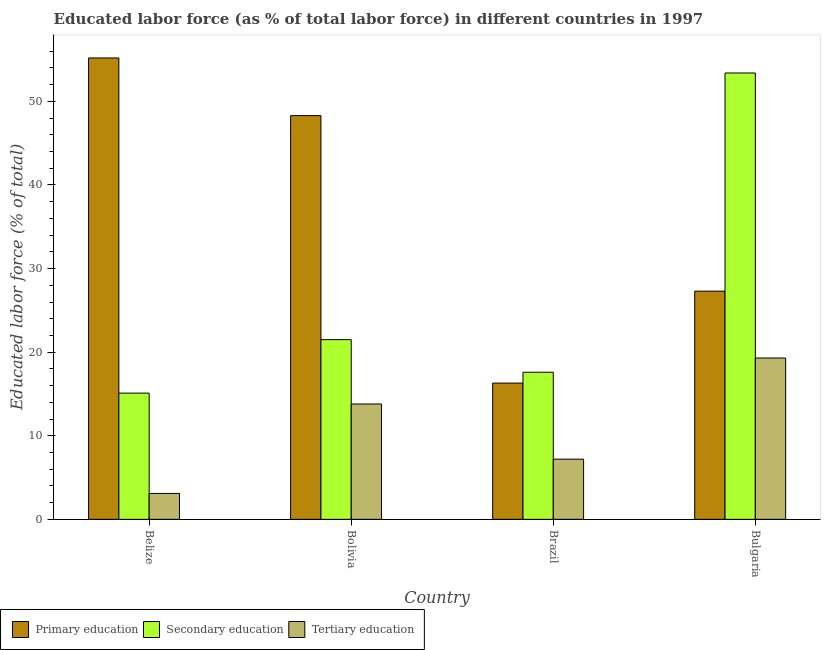Are the number of bars on each tick of the X-axis equal?
Your response must be concise. Yes. How many bars are there on the 2nd tick from the right?
Make the answer very short. 3. What is the label of the 3rd group of bars from the left?
Offer a very short reply. Brazil. In how many cases, is the number of bars for a given country not equal to the number of legend labels?
Make the answer very short. 0. What is the percentage of labor force who received primary education in Belize?
Make the answer very short. 55.2. Across all countries, what is the maximum percentage of labor force who received tertiary education?
Provide a short and direct response. 19.3. Across all countries, what is the minimum percentage of labor force who received secondary education?
Your response must be concise. 15.1. In which country was the percentage of labor force who received primary education maximum?
Your response must be concise. Belize. In which country was the percentage of labor force who received primary education minimum?
Offer a very short reply. Brazil. What is the total percentage of labor force who received primary education in the graph?
Make the answer very short. 147.1. What is the difference between the percentage of labor force who received primary education in Belize and that in Bulgaria?
Provide a short and direct response. 27.9. What is the difference between the percentage of labor force who received secondary education in Bolivia and the percentage of labor force who received primary education in Bulgaria?
Keep it short and to the point. -5.8. What is the average percentage of labor force who received primary education per country?
Provide a short and direct response. 36.77. What is the difference between the percentage of labor force who received primary education and percentage of labor force who received tertiary education in Belize?
Keep it short and to the point. 52.1. What is the ratio of the percentage of labor force who received primary education in Belize to that in Brazil?
Provide a succinct answer. 3.39. Is the percentage of labor force who received primary education in Belize less than that in Brazil?
Provide a short and direct response. No. What is the difference between the highest and the second highest percentage of labor force who received tertiary education?
Your answer should be very brief. 5.5. What is the difference between the highest and the lowest percentage of labor force who received secondary education?
Give a very brief answer. 38.3. Is the sum of the percentage of labor force who received primary education in Belize and Bolivia greater than the maximum percentage of labor force who received tertiary education across all countries?
Offer a very short reply. Yes. What does the 2nd bar from the left in Bulgaria represents?
Provide a short and direct response. Secondary education. What does the 1st bar from the right in Bulgaria represents?
Keep it short and to the point. Tertiary education. How many bars are there?
Ensure brevity in your answer.  12. Are all the bars in the graph horizontal?
Keep it short and to the point. No. How many countries are there in the graph?
Give a very brief answer. 4. What is the difference between two consecutive major ticks on the Y-axis?
Provide a short and direct response. 10. Are the values on the major ticks of Y-axis written in scientific E-notation?
Provide a succinct answer. No. Does the graph contain any zero values?
Your answer should be very brief. No. Where does the legend appear in the graph?
Your answer should be compact. Bottom left. How many legend labels are there?
Provide a short and direct response. 3. What is the title of the graph?
Ensure brevity in your answer.  Educated labor force (as % of total labor force) in different countries in 1997. Does "Poland" appear as one of the legend labels in the graph?
Your answer should be compact. No. What is the label or title of the Y-axis?
Offer a terse response. Educated labor force (% of total). What is the Educated labor force (% of total) of Primary education in Belize?
Ensure brevity in your answer.  55.2. What is the Educated labor force (% of total) of Secondary education in Belize?
Make the answer very short. 15.1. What is the Educated labor force (% of total) of Tertiary education in Belize?
Provide a short and direct response. 3.1. What is the Educated labor force (% of total) of Primary education in Bolivia?
Your answer should be compact. 48.3. What is the Educated labor force (% of total) in Tertiary education in Bolivia?
Keep it short and to the point. 13.8. What is the Educated labor force (% of total) in Primary education in Brazil?
Keep it short and to the point. 16.3. What is the Educated labor force (% of total) in Secondary education in Brazil?
Provide a succinct answer. 17.6. What is the Educated labor force (% of total) in Tertiary education in Brazil?
Ensure brevity in your answer.  7.2. What is the Educated labor force (% of total) in Primary education in Bulgaria?
Your answer should be compact. 27.3. What is the Educated labor force (% of total) of Secondary education in Bulgaria?
Make the answer very short. 53.4. What is the Educated labor force (% of total) of Tertiary education in Bulgaria?
Offer a terse response. 19.3. Across all countries, what is the maximum Educated labor force (% of total) of Primary education?
Provide a succinct answer. 55.2. Across all countries, what is the maximum Educated labor force (% of total) of Secondary education?
Your response must be concise. 53.4. Across all countries, what is the maximum Educated labor force (% of total) in Tertiary education?
Keep it short and to the point. 19.3. Across all countries, what is the minimum Educated labor force (% of total) of Primary education?
Offer a very short reply. 16.3. Across all countries, what is the minimum Educated labor force (% of total) of Secondary education?
Ensure brevity in your answer.  15.1. Across all countries, what is the minimum Educated labor force (% of total) of Tertiary education?
Your response must be concise. 3.1. What is the total Educated labor force (% of total) in Primary education in the graph?
Your answer should be compact. 147.1. What is the total Educated labor force (% of total) of Secondary education in the graph?
Your response must be concise. 107.6. What is the total Educated labor force (% of total) of Tertiary education in the graph?
Provide a succinct answer. 43.4. What is the difference between the Educated labor force (% of total) of Tertiary education in Belize and that in Bolivia?
Offer a terse response. -10.7. What is the difference between the Educated labor force (% of total) of Primary education in Belize and that in Brazil?
Give a very brief answer. 38.9. What is the difference between the Educated labor force (% of total) of Secondary education in Belize and that in Brazil?
Ensure brevity in your answer.  -2.5. What is the difference between the Educated labor force (% of total) of Tertiary education in Belize and that in Brazil?
Your response must be concise. -4.1. What is the difference between the Educated labor force (% of total) in Primary education in Belize and that in Bulgaria?
Your answer should be very brief. 27.9. What is the difference between the Educated labor force (% of total) in Secondary education in Belize and that in Bulgaria?
Offer a terse response. -38.3. What is the difference between the Educated labor force (% of total) of Tertiary education in Belize and that in Bulgaria?
Provide a succinct answer. -16.2. What is the difference between the Educated labor force (% of total) in Primary education in Bolivia and that in Bulgaria?
Offer a terse response. 21. What is the difference between the Educated labor force (% of total) of Secondary education in Bolivia and that in Bulgaria?
Your response must be concise. -31.9. What is the difference between the Educated labor force (% of total) of Primary education in Brazil and that in Bulgaria?
Offer a terse response. -11. What is the difference between the Educated labor force (% of total) of Secondary education in Brazil and that in Bulgaria?
Provide a succinct answer. -35.8. What is the difference between the Educated labor force (% of total) of Tertiary education in Brazil and that in Bulgaria?
Provide a succinct answer. -12.1. What is the difference between the Educated labor force (% of total) of Primary education in Belize and the Educated labor force (% of total) of Secondary education in Bolivia?
Keep it short and to the point. 33.7. What is the difference between the Educated labor force (% of total) of Primary education in Belize and the Educated labor force (% of total) of Tertiary education in Bolivia?
Give a very brief answer. 41.4. What is the difference between the Educated labor force (% of total) of Primary education in Belize and the Educated labor force (% of total) of Secondary education in Brazil?
Give a very brief answer. 37.6. What is the difference between the Educated labor force (% of total) in Primary education in Belize and the Educated labor force (% of total) in Tertiary education in Brazil?
Keep it short and to the point. 48. What is the difference between the Educated labor force (% of total) in Primary education in Belize and the Educated labor force (% of total) in Secondary education in Bulgaria?
Provide a succinct answer. 1.8. What is the difference between the Educated labor force (% of total) of Primary education in Belize and the Educated labor force (% of total) of Tertiary education in Bulgaria?
Your answer should be compact. 35.9. What is the difference between the Educated labor force (% of total) of Primary education in Bolivia and the Educated labor force (% of total) of Secondary education in Brazil?
Your answer should be very brief. 30.7. What is the difference between the Educated labor force (% of total) in Primary education in Bolivia and the Educated labor force (% of total) in Tertiary education in Brazil?
Provide a succinct answer. 41.1. What is the difference between the Educated labor force (% of total) in Primary education in Bolivia and the Educated labor force (% of total) in Tertiary education in Bulgaria?
Offer a very short reply. 29. What is the difference between the Educated labor force (% of total) in Primary education in Brazil and the Educated labor force (% of total) in Secondary education in Bulgaria?
Ensure brevity in your answer.  -37.1. What is the average Educated labor force (% of total) of Primary education per country?
Offer a very short reply. 36.77. What is the average Educated labor force (% of total) in Secondary education per country?
Offer a terse response. 26.9. What is the average Educated labor force (% of total) of Tertiary education per country?
Your answer should be compact. 10.85. What is the difference between the Educated labor force (% of total) in Primary education and Educated labor force (% of total) in Secondary education in Belize?
Offer a terse response. 40.1. What is the difference between the Educated labor force (% of total) of Primary education and Educated labor force (% of total) of Tertiary education in Belize?
Your answer should be very brief. 52.1. What is the difference between the Educated labor force (% of total) in Primary education and Educated labor force (% of total) in Secondary education in Bolivia?
Provide a succinct answer. 26.8. What is the difference between the Educated labor force (% of total) in Primary education and Educated labor force (% of total) in Tertiary education in Bolivia?
Offer a terse response. 34.5. What is the difference between the Educated labor force (% of total) in Secondary education and Educated labor force (% of total) in Tertiary education in Bolivia?
Your response must be concise. 7.7. What is the difference between the Educated labor force (% of total) of Primary education and Educated labor force (% of total) of Secondary education in Brazil?
Keep it short and to the point. -1.3. What is the difference between the Educated labor force (% of total) of Secondary education and Educated labor force (% of total) of Tertiary education in Brazil?
Provide a succinct answer. 10.4. What is the difference between the Educated labor force (% of total) of Primary education and Educated labor force (% of total) of Secondary education in Bulgaria?
Your answer should be compact. -26.1. What is the difference between the Educated labor force (% of total) of Primary education and Educated labor force (% of total) of Tertiary education in Bulgaria?
Make the answer very short. 8. What is the difference between the Educated labor force (% of total) of Secondary education and Educated labor force (% of total) of Tertiary education in Bulgaria?
Your response must be concise. 34.1. What is the ratio of the Educated labor force (% of total) in Primary education in Belize to that in Bolivia?
Make the answer very short. 1.14. What is the ratio of the Educated labor force (% of total) of Secondary education in Belize to that in Bolivia?
Offer a very short reply. 0.7. What is the ratio of the Educated labor force (% of total) of Tertiary education in Belize to that in Bolivia?
Keep it short and to the point. 0.22. What is the ratio of the Educated labor force (% of total) of Primary education in Belize to that in Brazil?
Ensure brevity in your answer.  3.39. What is the ratio of the Educated labor force (% of total) of Secondary education in Belize to that in Brazil?
Your answer should be compact. 0.86. What is the ratio of the Educated labor force (% of total) of Tertiary education in Belize to that in Brazil?
Keep it short and to the point. 0.43. What is the ratio of the Educated labor force (% of total) of Primary education in Belize to that in Bulgaria?
Ensure brevity in your answer.  2.02. What is the ratio of the Educated labor force (% of total) in Secondary education in Belize to that in Bulgaria?
Provide a succinct answer. 0.28. What is the ratio of the Educated labor force (% of total) in Tertiary education in Belize to that in Bulgaria?
Give a very brief answer. 0.16. What is the ratio of the Educated labor force (% of total) of Primary education in Bolivia to that in Brazil?
Your answer should be very brief. 2.96. What is the ratio of the Educated labor force (% of total) of Secondary education in Bolivia to that in Brazil?
Your answer should be compact. 1.22. What is the ratio of the Educated labor force (% of total) in Tertiary education in Bolivia to that in Brazil?
Give a very brief answer. 1.92. What is the ratio of the Educated labor force (% of total) in Primary education in Bolivia to that in Bulgaria?
Provide a succinct answer. 1.77. What is the ratio of the Educated labor force (% of total) in Secondary education in Bolivia to that in Bulgaria?
Your response must be concise. 0.4. What is the ratio of the Educated labor force (% of total) in Tertiary education in Bolivia to that in Bulgaria?
Provide a short and direct response. 0.71. What is the ratio of the Educated labor force (% of total) of Primary education in Brazil to that in Bulgaria?
Your response must be concise. 0.6. What is the ratio of the Educated labor force (% of total) of Secondary education in Brazil to that in Bulgaria?
Make the answer very short. 0.33. What is the ratio of the Educated labor force (% of total) of Tertiary education in Brazil to that in Bulgaria?
Offer a terse response. 0.37. What is the difference between the highest and the second highest Educated labor force (% of total) of Secondary education?
Offer a terse response. 31.9. What is the difference between the highest and the lowest Educated labor force (% of total) in Primary education?
Ensure brevity in your answer.  38.9. What is the difference between the highest and the lowest Educated labor force (% of total) of Secondary education?
Keep it short and to the point. 38.3. What is the difference between the highest and the lowest Educated labor force (% of total) of Tertiary education?
Offer a terse response. 16.2. 